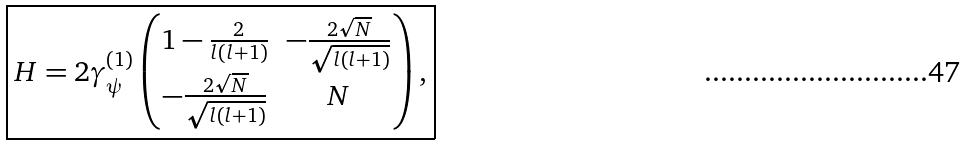Convert formula to latex. <formula><loc_0><loc_0><loc_500><loc_500>\boxed { H = 2 \gamma _ { \psi } ^ { ( 1 ) } \begin{pmatrix} 1 - \frac { 2 } { l ( l + 1 ) } & - \frac { 2 \sqrt { N } } { \sqrt { l ( l + 1 ) } } \\ - \frac { 2 \sqrt { N } } { \sqrt { l ( l + 1 ) } } & N \end{pmatrix} , }</formula> 